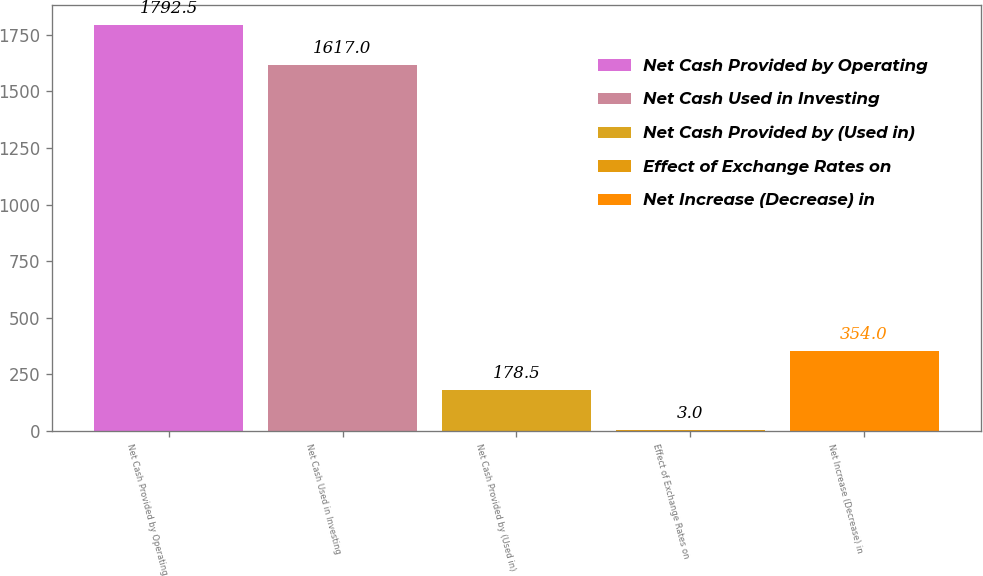Convert chart to OTSL. <chart><loc_0><loc_0><loc_500><loc_500><bar_chart><fcel>Net Cash Provided by Operating<fcel>Net Cash Used in Investing<fcel>Net Cash Provided by (Used in)<fcel>Effect of Exchange Rates on<fcel>Net Increase (Decrease) in<nl><fcel>1792.5<fcel>1617<fcel>178.5<fcel>3<fcel>354<nl></chart> 